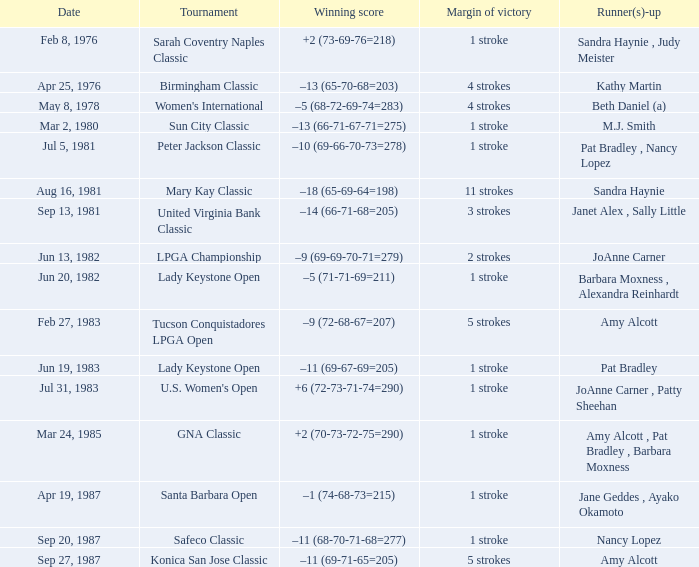Which competition has a winning score of -9 (69-69-70-71=279)? LPGA Championship. 